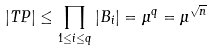Convert formula to latex. <formula><loc_0><loc_0><loc_500><loc_500>| T P | \leq \prod _ { 1 \leq i \leq q } | B _ { i } | = \mu ^ { q } = \mu ^ { \sqrt { n } }</formula> 